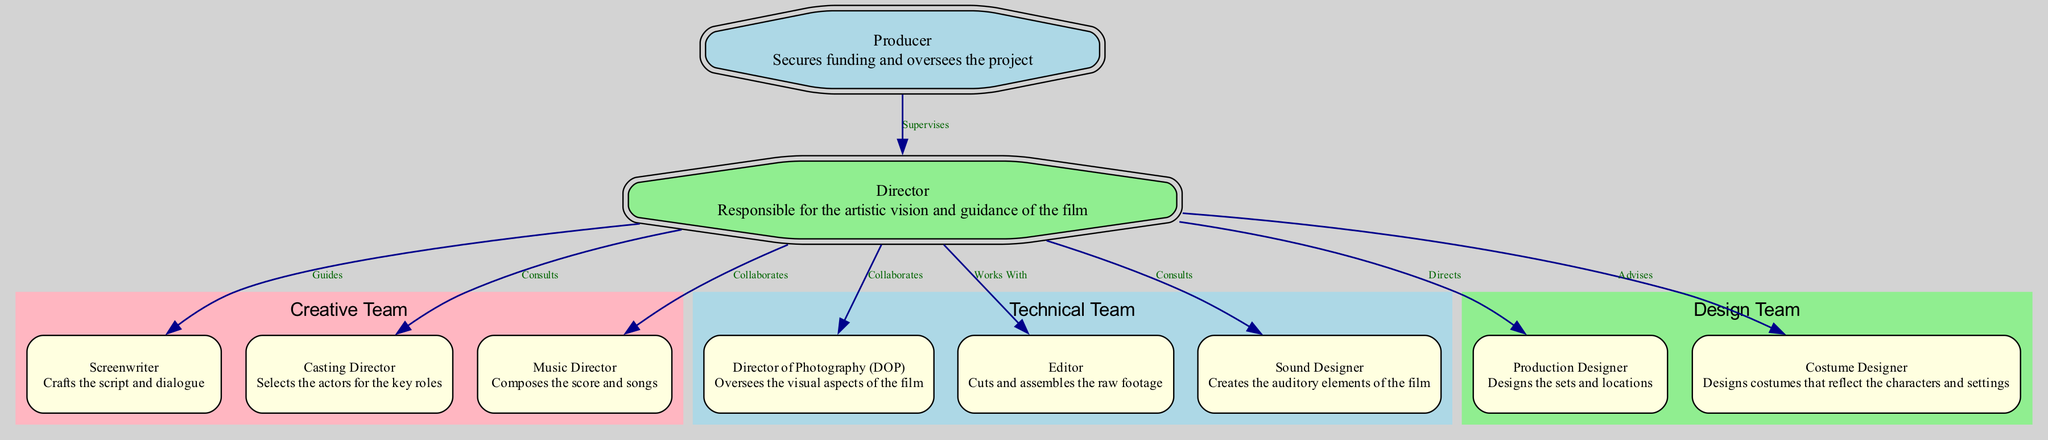What is the primary responsibility of the Producer? The Producer secures funding and oversees the project, as indicated in the node description.
Answer: Secures funding and oversees the project Who does the Director work with to cut and assemble the raw footage? The Director works with the Editor, as shown by the connection (edge) between the Director and Editor in the diagram.
Answer: Editor How many key roles are represented in the diagram? There are ten nodes listed, each representing a key role in the Telugu film production process.
Answer: Ten What role does the Casting Director have in relation to the Director? The Casting Director is selected by the Director, as shown by the "Consults" relationship depicted in the diagram.
Answer: Consults Which team includes the Director of Photography? The Director of Photography is part of the Technical Team, as indicated by the subgraph and the associated node colors.
Answer: Technical Team Who does the Sound Designer collaborate with? The Sound Designer collaborates with the Director, as indicated by their mutual connection in the diagram.
Answer: Director What is the function of the Production Designer? The Production Designer designs the sets and locations for the film, as noted in the role description within the corresponding node.
Answer: Designs the sets and locations How many relationships connect the Director to other roles? The Director has nine relationships connecting to other roles, indicating collaboration or guidance throughout the production process.
Answer: Nine In what capacity does the Music Director work with the Director? The Music Director collaborates with the Director, as shown in the diagram through the "Collaborates" relationship between the two nodes.
Answer: Collaborates 